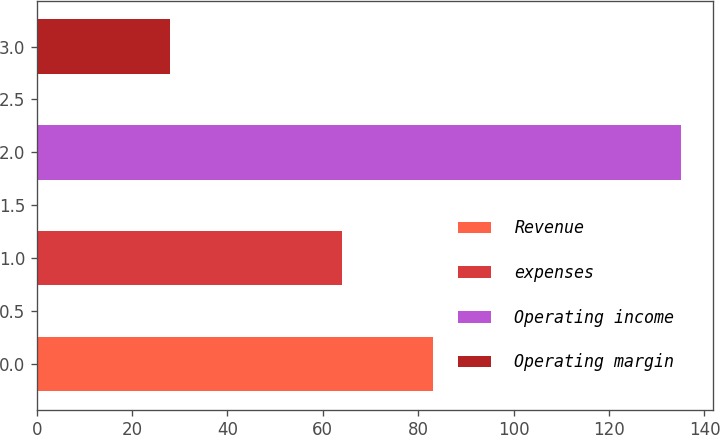Convert chart to OTSL. <chart><loc_0><loc_0><loc_500><loc_500><bar_chart><fcel>Revenue<fcel>expenses<fcel>Operating income<fcel>Operating margin<nl><fcel>83<fcel>64<fcel>135<fcel>28<nl></chart> 